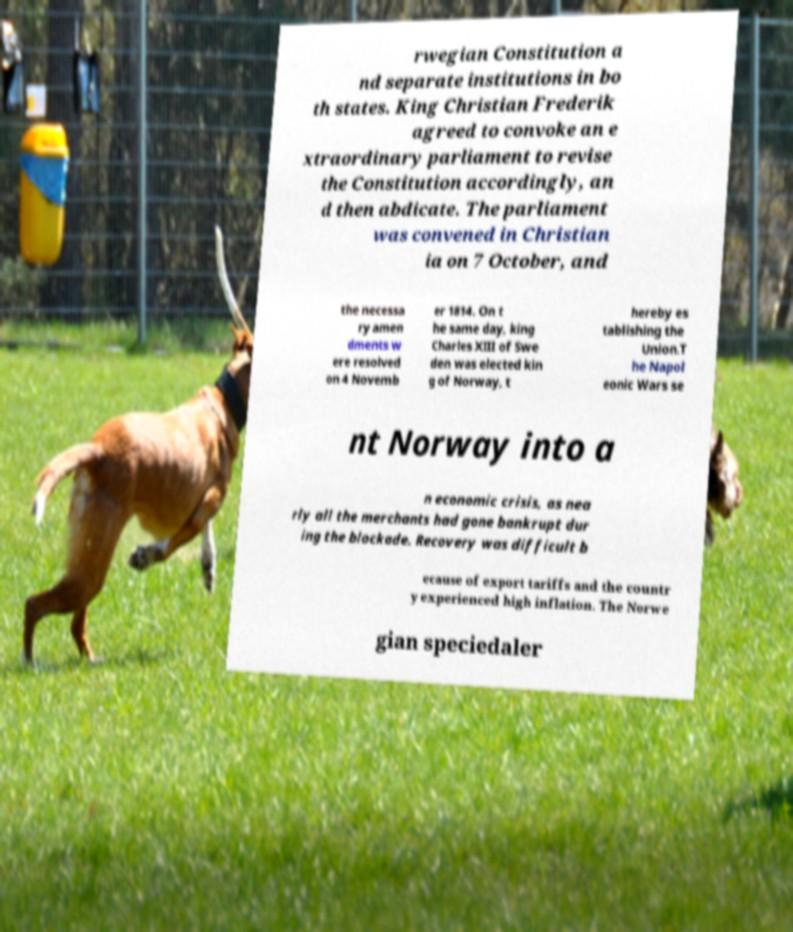Could you extract and type out the text from this image? rwegian Constitution a nd separate institutions in bo th states. King Christian Frederik agreed to convoke an e xtraordinary parliament to revise the Constitution accordingly, an d then abdicate. The parliament was convened in Christian ia on 7 October, and the necessa ry amen dments w ere resolved on 4 Novemb er 1814. On t he same day, king Charles XIII of Swe den was elected kin g of Norway, t hereby es tablishing the Union.T he Napol eonic Wars se nt Norway into a n economic crisis, as nea rly all the merchants had gone bankrupt dur ing the blockade. Recovery was difficult b ecause of export tariffs and the countr y experienced high inflation. The Norwe gian speciedaler 